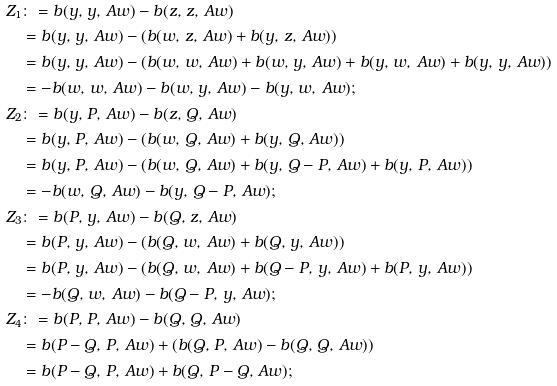<formula> <loc_0><loc_0><loc_500><loc_500>Z _ { 1 } & \colon = b ( y , \, y , \, A w ) - b ( z , \, z , \, A w ) \\ & = b ( y , \, y , \, A w ) - \left ( b ( w , \, z , \, A w ) + b ( y , \, z , \, A w ) \right ) \\ & = b ( y , \, y , \, A w ) - \left ( b ( w , \, w , \, A w ) + b ( w , \, y , \, A w ) + b ( y , \, w , \, A w ) + b ( y , \, y , \, A w ) \right ) \\ & = - b ( w , \, w , \, A w ) - b ( w , \, y , \, A w ) - b ( y , \, w , \, A w ) ; \\ Z _ { 2 } & \colon = b ( y , \, P , \, A w ) - b ( z , \, Q , \, A w ) \\ & = b ( y , \, P , \, A w ) - \left ( b ( w , \, Q , \, A w ) + b ( y , \, Q , \, A w ) \right ) \\ & = b ( y , \, P , \, A w ) - \left ( b ( w , \, Q , \, A w ) + b ( y , \, Q - P , \, A w ) + b ( y , \, P , \, A w ) \right ) \\ & = - b ( w , \, Q , \, A w ) - b ( y , \, Q - P , \, A w ) ; \\ Z _ { 3 } & \colon = b ( P , \, y , \, A w ) - b ( Q , \, z , \, A w ) \\ & = b ( P , \, y , \, A w ) - \left ( b ( Q , \, w , \, A w ) + b ( Q , \, y , \, A w ) \right ) \\ & = b ( P , \, y , \, A w ) - \left ( b ( Q , \, w , \, A w ) + b ( Q - P , \, y , \, A w ) + b ( P , \, y , \, A w ) \right ) \\ & = - b ( Q , \, w , \, A w ) - b ( Q - P , \, y , \, A w ) ; \\ Z _ { 4 } & \colon = b ( P , \, P , \, A w ) - b ( Q , \, Q , \, A w ) \\ & = b ( P - Q , \, P , \, A w ) + \left ( b ( Q , \, P , \, A w ) - b ( Q , \, Q , \, A w ) \right ) \\ & = b ( P - Q , \, P , \, A w ) + b ( Q , \, P - Q , \, A w ) ;</formula> 